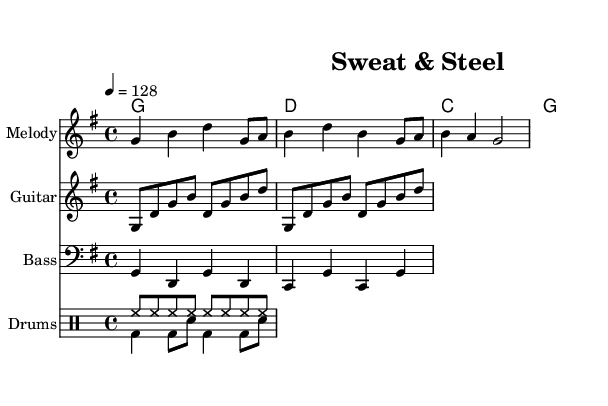What is the key signature of this music? The key signature is G major, which has one sharp (F#). This can be determined by looking at the key signature section at the beginning of the score.
Answer: G major What is the time signature of this music? The time signature is 4/4, indicating that there are four beats in each measure and the quarter note gets one beat. This can be observed at the beginning of the score.
Answer: 4/4 What is the tempo marking of this piece? The tempo marking is 128 beats per minute, indicated by the "4 = 128" notation in the score. This tells musicians how fast to play the piece.
Answer: 128 How many measures does the melody contain? The melody consists of 3 measures, which can be counted by looking at the grouping of notes in the melody staff.
Answer: 3 What instruments are featured in the arrangement? The arrangement includes melody, guitar, bass, and drums. This is indicated by the labels for each staff in the score.
Answer: Melody, Guitar, Bass, Drums Which chord is played in the first measure? The chord in the first measure is G major. This can be identified by looking at the chord names written above the staff at the beginning of the piece.
Answer: G major How many different parts are there in the drum staff? There are two different parts in the drum staff, indicated by the two separate drum voices labeled in the score.
Answer: 2 